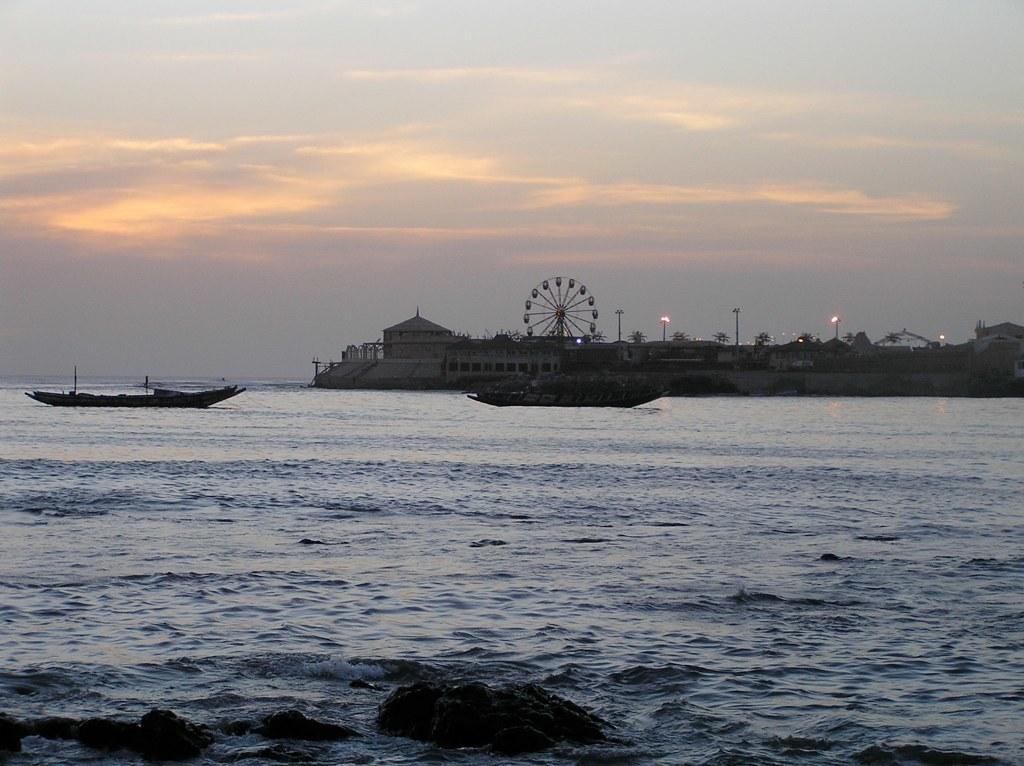Could you give a brief overview of what you see in this image? This picture shows couple of boats in the water and we see building and few trees and few pole lights and we see a giant wheel and a cloudy sky and few rocks in the water. 